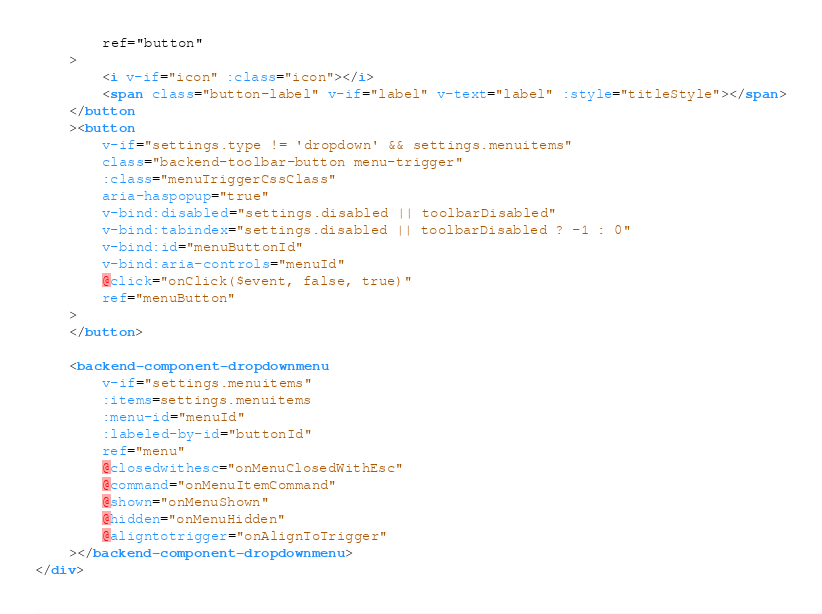<code> <loc_0><loc_0><loc_500><loc_500><_HTML_>        ref="button"
    >
        <i v-if="icon" :class="icon"></i>
        <span class="button-label" v-if="label" v-text="label" :style="titleStyle"></span>
    </button
    ><button
        v-if="settings.type != 'dropdown' && settings.menuitems"
        class="backend-toolbar-button menu-trigger"
        :class="menuTriggerCssClass"
        aria-haspopup="true"
        v-bind:disabled="settings.disabled || toolbarDisabled"
        v-bind:tabindex="settings.disabled || toolbarDisabled ? -1 : 0"
        v-bind:id="menuButtonId"
        v-bind:aria-controls="menuId"
        @click="onClick($event, false, true)"
        ref="menuButton"
    >
    </button>

    <backend-component-dropdownmenu
        v-if="settings.menuitems"
        :items=settings.menuitems
        :menu-id="menuId"
        :labeled-by-id="buttonId"
        ref="menu"
        @closedwithesc="onMenuClosedWithEsc"
        @command="onMenuItemCommand"
        @shown="onMenuShown"
        @hidden="onMenuHidden"
        @aligntotrigger="onAlignToTrigger"
    ></backend-component-dropdownmenu>
</div></code> 